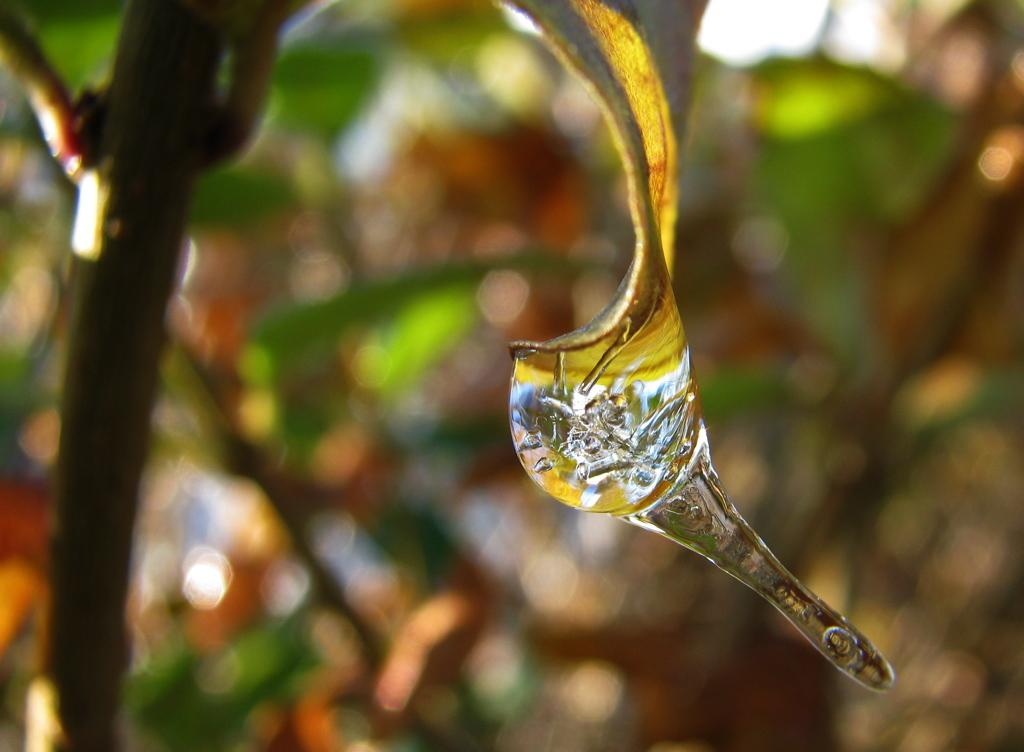What is the main subject of the image? The main subject of the image is a water drop on a leaf. Can you describe the background of the image? The background of the image is blurred. What type of salt can be seen on the plate in the image? There is no plate or salt present in the image; it features a water drop on a leaf with a blurred background. What is the cause of the war depicted in the image? There is no war depicted in the image; it features a water drop on a leaf with a blurred background. 